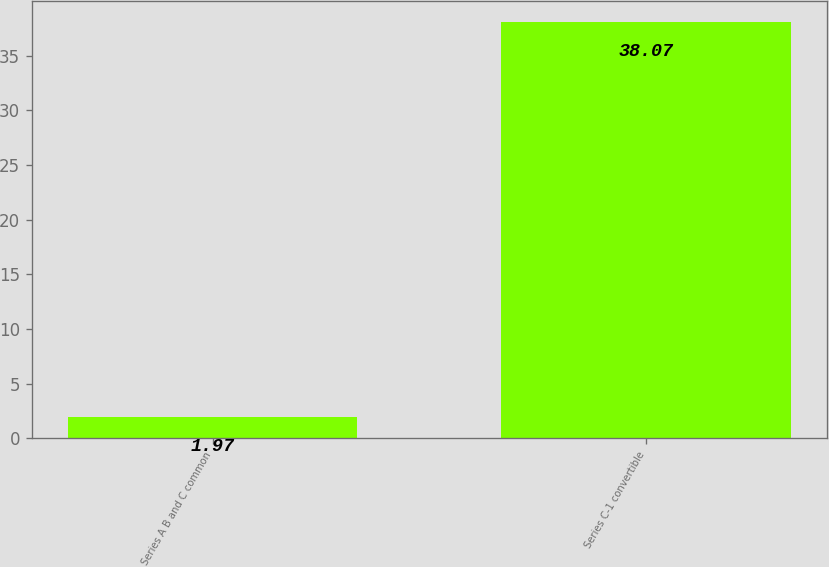Convert chart to OTSL. <chart><loc_0><loc_0><loc_500><loc_500><bar_chart><fcel>Series A B and C common<fcel>Series C-1 convertible<nl><fcel>1.97<fcel>38.07<nl></chart> 